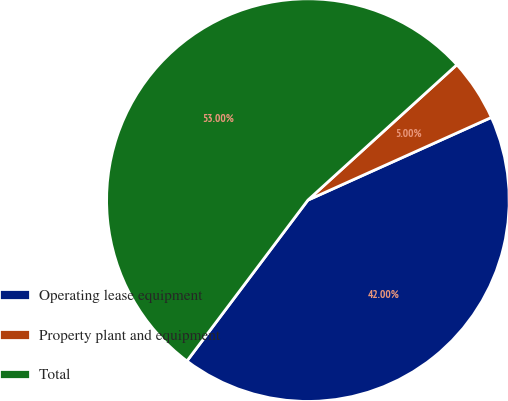Convert chart. <chart><loc_0><loc_0><loc_500><loc_500><pie_chart><fcel>Operating lease equipment<fcel>Property plant and equipment<fcel>Total<nl><fcel>42.0%<fcel>5.0%<fcel>53.0%<nl></chart> 